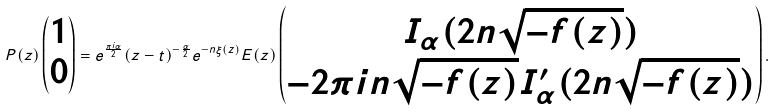<formula> <loc_0><loc_0><loc_500><loc_500>P ( z ) \begin{pmatrix} 1 \\ 0 \end{pmatrix} = e ^ { \frac { \pi i \alpha } { 2 } } ( z - t ) ^ { - \frac { \alpha } { 2 } } e ^ { - n \xi ( z ) } E ( z ) \begin{pmatrix} I _ { \alpha } ( 2 n \sqrt { - f ( z ) } ) \\ - 2 \pi i n \sqrt { - f ( z ) } I _ { \alpha } ^ { \prime } ( 2 n \sqrt { - f ( z ) } ) \end{pmatrix} .</formula> 